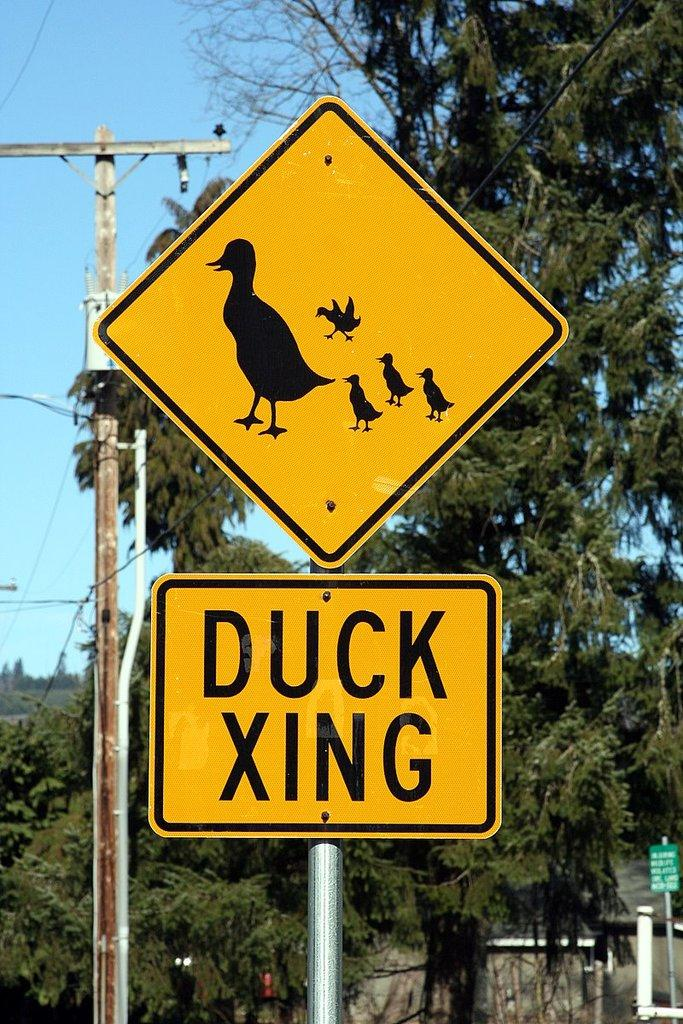<image>
Describe the image concisely. A yellow and black diamond shaped sign with ducks on it is above a rectangular sign that says "Duck Xing". 